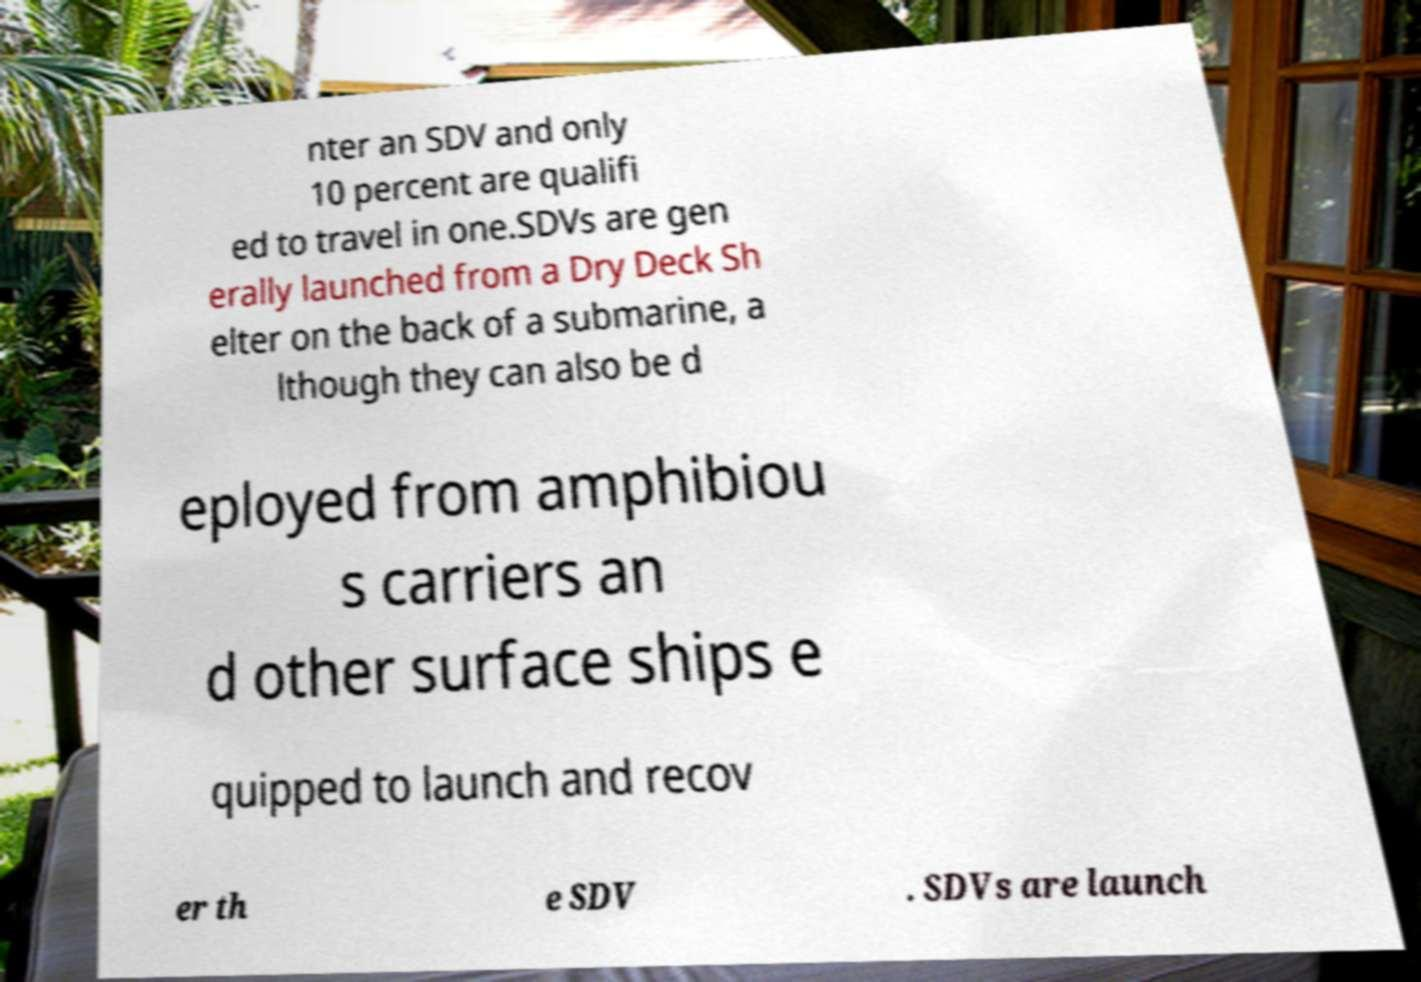Can you accurately transcribe the text from the provided image for me? nter an SDV and only 10 percent are qualifi ed to travel in one.SDVs are gen erally launched from a Dry Deck Sh elter on the back of a submarine, a lthough they can also be d eployed from amphibiou s carriers an d other surface ships e quipped to launch and recov er th e SDV . SDVs are launch 